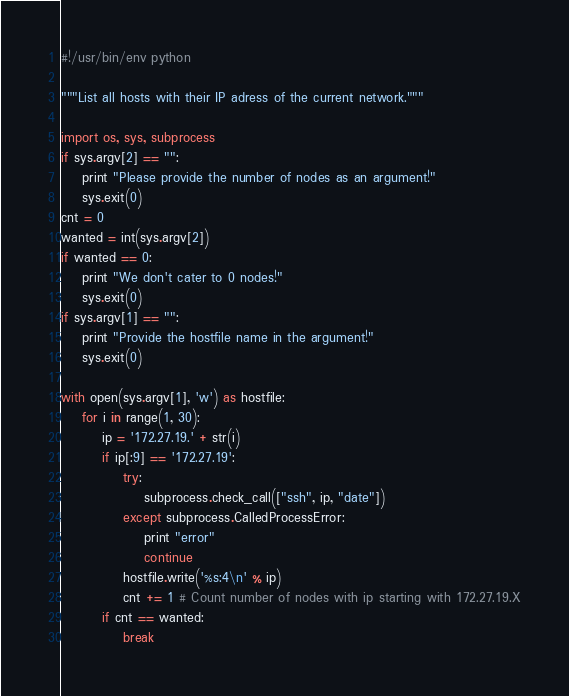Convert code to text. <code><loc_0><loc_0><loc_500><loc_500><_Python_>#!/usr/bin/env python

"""List all hosts with their IP adress of the current network."""

import os, sys, subprocess
if sys.argv[2] == "":
	print "Please provide the number of nodes as an argument!"
	sys.exit(0)
cnt = 0
wanted = int(sys.argv[2])
if wanted == 0:
	print "We don't cater to 0 nodes!"
	sys.exit(0)
if sys.argv[1] == "":
	print "Provide the hostfile name in the argument!"
	sys.exit(0)

with open(sys.argv[1], 'w') as hostfile:
	for i in range(1, 30):
		ip = '172.27.19.' + str(i)
		if ip[:9] == '172.27.19':
			try:
				subprocess.check_call(["ssh", ip, "date"])
			except subprocess.CalledProcessError:
				print "error"
				continue
			hostfile.write('%s:4\n' % ip)
			cnt += 1 # Count number of nodes with ip starting with 172.27.19.X
		if cnt == wanted:
			break
</code> 